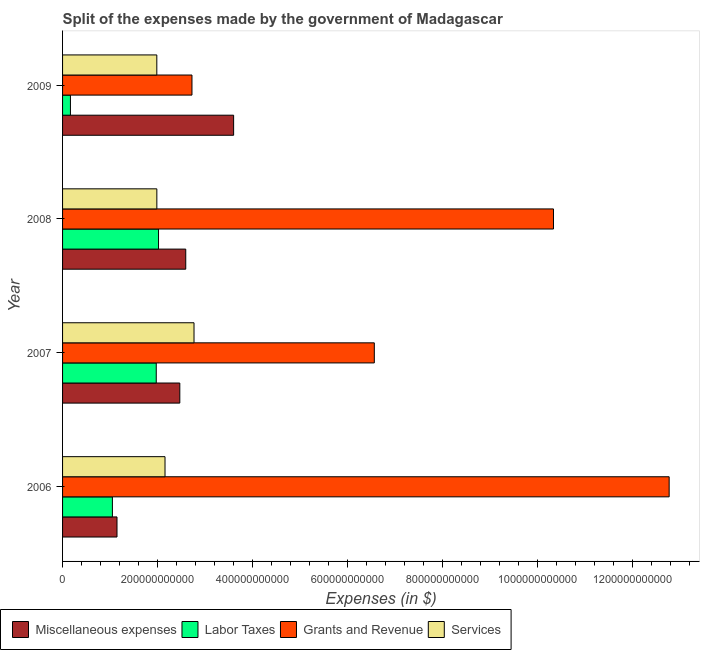How many groups of bars are there?
Offer a very short reply. 4. Are the number of bars on each tick of the Y-axis equal?
Make the answer very short. Yes. How many bars are there on the 4th tick from the top?
Make the answer very short. 4. How many bars are there on the 2nd tick from the bottom?
Offer a terse response. 4. What is the label of the 3rd group of bars from the top?
Give a very brief answer. 2007. What is the amount spent on labor taxes in 2006?
Offer a terse response. 1.05e+11. Across all years, what is the maximum amount spent on grants and revenue?
Keep it short and to the point. 1.28e+12. Across all years, what is the minimum amount spent on labor taxes?
Your response must be concise. 1.66e+1. In which year was the amount spent on labor taxes maximum?
Provide a short and direct response. 2008. In which year was the amount spent on miscellaneous expenses minimum?
Give a very brief answer. 2006. What is the total amount spent on services in the graph?
Ensure brevity in your answer.  8.89e+11. What is the difference between the amount spent on services in 2007 and that in 2009?
Your answer should be compact. 7.83e+1. What is the difference between the amount spent on miscellaneous expenses in 2007 and the amount spent on grants and revenue in 2008?
Offer a very short reply. -7.87e+11. What is the average amount spent on labor taxes per year?
Ensure brevity in your answer.  1.30e+11. In the year 2008, what is the difference between the amount spent on services and amount spent on miscellaneous expenses?
Offer a very short reply. -6.08e+1. In how many years, is the amount spent on grants and revenue greater than 1080000000000 $?
Make the answer very short. 1. What is the difference between the highest and the second highest amount spent on services?
Offer a terse response. 6.11e+1. What is the difference between the highest and the lowest amount spent on grants and revenue?
Ensure brevity in your answer.  1.00e+12. Is the sum of the amount spent on grants and revenue in 2007 and 2009 greater than the maximum amount spent on services across all years?
Offer a terse response. Yes. What does the 3rd bar from the top in 2008 represents?
Your answer should be compact. Labor Taxes. What does the 2nd bar from the bottom in 2009 represents?
Ensure brevity in your answer.  Labor Taxes. Is it the case that in every year, the sum of the amount spent on miscellaneous expenses and amount spent on labor taxes is greater than the amount spent on grants and revenue?
Offer a terse response. No. Are all the bars in the graph horizontal?
Provide a succinct answer. Yes. How many years are there in the graph?
Your answer should be compact. 4. What is the difference between two consecutive major ticks on the X-axis?
Make the answer very short. 2.00e+11. Are the values on the major ticks of X-axis written in scientific E-notation?
Provide a succinct answer. No. What is the title of the graph?
Offer a terse response. Split of the expenses made by the government of Madagascar. Does "Agriculture" appear as one of the legend labels in the graph?
Provide a succinct answer. No. What is the label or title of the X-axis?
Your response must be concise. Expenses (in $). What is the Expenses (in $) in Miscellaneous expenses in 2006?
Ensure brevity in your answer.  1.15e+11. What is the Expenses (in $) of Labor Taxes in 2006?
Provide a succinct answer. 1.05e+11. What is the Expenses (in $) in Grants and Revenue in 2006?
Provide a succinct answer. 1.28e+12. What is the Expenses (in $) in Services in 2006?
Make the answer very short. 2.16e+11. What is the Expenses (in $) in Miscellaneous expenses in 2007?
Provide a succinct answer. 2.47e+11. What is the Expenses (in $) of Labor Taxes in 2007?
Make the answer very short. 1.97e+11. What is the Expenses (in $) in Grants and Revenue in 2007?
Keep it short and to the point. 6.56e+11. What is the Expenses (in $) of Services in 2007?
Provide a succinct answer. 2.77e+11. What is the Expenses (in $) in Miscellaneous expenses in 2008?
Your response must be concise. 2.59e+11. What is the Expenses (in $) of Labor Taxes in 2008?
Your answer should be compact. 2.02e+11. What is the Expenses (in $) of Grants and Revenue in 2008?
Your answer should be very brief. 1.03e+12. What is the Expenses (in $) of Services in 2008?
Your response must be concise. 1.98e+11. What is the Expenses (in $) of Miscellaneous expenses in 2009?
Your answer should be very brief. 3.60e+11. What is the Expenses (in $) of Labor Taxes in 2009?
Offer a terse response. 1.66e+1. What is the Expenses (in $) of Grants and Revenue in 2009?
Provide a short and direct response. 2.72e+11. What is the Expenses (in $) in Services in 2009?
Provide a succinct answer. 1.98e+11. Across all years, what is the maximum Expenses (in $) in Miscellaneous expenses?
Offer a terse response. 3.60e+11. Across all years, what is the maximum Expenses (in $) of Labor Taxes?
Your answer should be compact. 2.02e+11. Across all years, what is the maximum Expenses (in $) of Grants and Revenue?
Offer a terse response. 1.28e+12. Across all years, what is the maximum Expenses (in $) in Services?
Offer a terse response. 2.77e+11. Across all years, what is the minimum Expenses (in $) in Miscellaneous expenses?
Your response must be concise. 1.15e+11. Across all years, what is the minimum Expenses (in $) of Labor Taxes?
Keep it short and to the point. 1.66e+1. Across all years, what is the minimum Expenses (in $) of Grants and Revenue?
Offer a terse response. 2.72e+11. Across all years, what is the minimum Expenses (in $) of Services?
Offer a terse response. 1.98e+11. What is the total Expenses (in $) of Miscellaneous expenses in the graph?
Make the answer very short. 9.81e+11. What is the total Expenses (in $) of Labor Taxes in the graph?
Your answer should be very brief. 5.21e+11. What is the total Expenses (in $) in Grants and Revenue in the graph?
Ensure brevity in your answer.  3.24e+12. What is the total Expenses (in $) of Services in the graph?
Keep it short and to the point. 8.89e+11. What is the difference between the Expenses (in $) in Miscellaneous expenses in 2006 and that in 2007?
Keep it short and to the point. -1.32e+11. What is the difference between the Expenses (in $) of Labor Taxes in 2006 and that in 2007?
Give a very brief answer. -9.23e+1. What is the difference between the Expenses (in $) in Grants and Revenue in 2006 and that in 2007?
Your answer should be compact. 6.21e+11. What is the difference between the Expenses (in $) in Services in 2006 and that in 2007?
Provide a short and direct response. -6.11e+1. What is the difference between the Expenses (in $) of Miscellaneous expenses in 2006 and that in 2008?
Keep it short and to the point. -1.45e+11. What is the difference between the Expenses (in $) of Labor Taxes in 2006 and that in 2008?
Keep it short and to the point. -9.71e+1. What is the difference between the Expenses (in $) of Grants and Revenue in 2006 and that in 2008?
Give a very brief answer. 2.44e+11. What is the difference between the Expenses (in $) of Services in 2006 and that in 2008?
Your response must be concise. 1.72e+1. What is the difference between the Expenses (in $) in Miscellaneous expenses in 2006 and that in 2009?
Your response must be concise. -2.45e+11. What is the difference between the Expenses (in $) of Labor Taxes in 2006 and that in 2009?
Provide a short and direct response. 8.83e+1. What is the difference between the Expenses (in $) in Grants and Revenue in 2006 and that in 2009?
Your answer should be very brief. 1.00e+12. What is the difference between the Expenses (in $) of Services in 2006 and that in 2009?
Keep it short and to the point. 1.73e+1. What is the difference between the Expenses (in $) in Miscellaneous expenses in 2007 and that in 2008?
Your answer should be compact. -1.25e+1. What is the difference between the Expenses (in $) of Labor Taxes in 2007 and that in 2008?
Offer a terse response. -4.78e+09. What is the difference between the Expenses (in $) in Grants and Revenue in 2007 and that in 2008?
Provide a short and direct response. -3.77e+11. What is the difference between the Expenses (in $) of Services in 2007 and that in 2008?
Offer a very short reply. 7.82e+1. What is the difference between the Expenses (in $) in Miscellaneous expenses in 2007 and that in 2009?
Your answer should be compact. -1.13e+11. What is the difference between the Expenses (in $) of Labor Taxes in 2007 and that in 2009?
Your answer should be compact. 1.81e+11. What is the difference between the Expenses (in $) in Grants and Revenue in 2007 and that in 2009?
Provide a succinct answer. 3.84e+11. What is the difference between the Expenses (in $) of Services in 2007 and that in 2009?
Your answer should be very brief. 7.83e+1. What is the difference between the Expenses (in $) of Miscellaneous expenses in 2008 and that in 2009?
Provide a short and direct response. -1.01e+11. What is the difference between the Expenses (in $) of Labor Taxes in 2008 and that in 2009?
Your answer should be compact. 1.85e+11. What is the difference between the Expenses (in $) in Grants and Revenue in 2008 and that in 2009?
Provide a short and direct response. 7.61e+11. What is the difference between the Expenses (in $) of Services in 2008 and that in 2009?
Your answer should be very brief. 9.30e+07. What is the difference between the Expenses (in $) of Miscellaneous expenses in 2006 and the Expenses (in $) of Labor Taxes in 2007?
Ensure brevity in your answer.  -8.26e+1. What is the difference between the Expenses (in $) in Miscellaneous expenses in 2006 and the Expenses (in $) in Grants and Revenue in 2007?
Make the answer very short. -5.42e+11. What is the difference between the Expenses (in $) of Miscellaneous expenses in 2006 and the Expenses (in $) of Services in 2007?
Your response must be concise. -1.62e+11. What is the difference between the Expenses (in $) of Labor Taxes in 2006 and the Expenses (in $) of Grants and Revenue in 2007?
Your answer should be very brief. -5.51e+11. What is the difference between the Expenses (in $) in Labor Taxes in 2006 and the Expenses (in $) in Services in 2007?
Provide a short and direct response. -1.72e+11. What is the difference between the Expenses (in $) of Grants and Revenue in 2006 and the Expenses (in $) of Services in 2007?
Make the answer very short. 1.00e+12. What is the difference between the Expenses (in $) of Miscellaneous expenses in 2006 and the Expenses (in $) of Labor Taxes in 2008?
Your response must be concise. -8.74e+1. What is the difference between the Expenses (in $) of Miscellaneous expenses in 2006 and the Expenses (in $) of Grants and Revenue in 2008?
Your response must be concise. -9.19e+11. What is the difference between the Expenses (in $) in Miscellaneous expenses in 2006 and the Expenses (in $) in Services in 2008?
Offer a very short reply. -8.39e+1. What is the difference between the Expenses (in $) in Labor Taxes in 2006 and the Expenses (in $) in Grants and Revenue in 2008?
Provide a succinct answer. -9.28e+11. What is the difference between the Expenses (in $) in Labor Taxes in 2006 and the Expenses (in $) in Services in 2008?
Your answer should be compact. -9.36e+1. What is the difference between the Expenses (in $) of Grants and Revenue in 2006 and the Expenses (in $) of Services in 2008?
Make the answer very short. 1.08e+12. What is the difference between the Expenses (in $) of Miscellaneous expenses in 2006 and the Expenses (in $) of Labor Taxes in 2009?
Make the answer very short. 9.80e+1. What is the difference between the Expenses (in $) in Miscellaneous expenses in 2006 and the Expenses (in $) in Grants and Revenue in 2009?
Ensure brevity in your answer.  -1.58e+11. What is the difference between the Expenses (in $) in Miscellaneous expenses in 2006 and the Expenses (in $) in Services in 2009?
Make the answer very short. -8.38e+1. What is the difference between the Expenses (in $) in Labor Taxes in 2006 and the Expenses (in $) in Grants and Revenue in 2009?
Offer a terse response. -1.68e+11. What is the difference between the Expenses (in $) of Labor Taxes in 2006 and the Expenses (in $) of Services in 2009?
Give a very brief answer. -9.35e+1. What is the difference between the Expenses (in $) in Grants and Revenue in 2006 and the Expenses (in $) in Services in 2009?
Your answer should be compact. 1.08e+12. What is the difference between the Expenses (in $) of Miscellaneous expenses in 2007 and the Expenses (in $) of Labor Taxes in 2008?
Ensure brevity in your answer.  4.48e+1. What is the difference between the Expenses (in $) of Miscellaneous expenses in 2007 and the Expenses (in $) of Grants and Revenue in 2008?
Provide a short and direct response. -7.87e+11. What is the difference between the Expenses (in $) in Miscellaneous expenses in 2007 and the Expenses (in $) in Services in 2008?
Keep it short and to the point. 4.83e+1. What is the difference between the Expenses (in $) in Labor Taxes in 2007 and the Expenses (in $) in Grants and Revenue in 2008?
Offer a terse response. -8.36e+11. What is the difference between the Expenses (in $) of Labor Taxes in 2007 and the Expenses (in $) of Services in 2008?
Your response must be concise. -1.25e+09. What is the difference between the Expenses (in $) in Grants and Revenue in 2007 and the Expenses (in $) in Services in 2008?
Ensure brevity in your answer.  4.58e+11. What is the difference between the Expenses (in $) in Miscellaneous expenses in 2007 and the Expenses (in $) in Labor Taxes in 2009?
Offer a terse response. 2.30e+11. What is the difference between the Expenses (in $) in Miscellaneous expenses in 2007 and the Expenses (in $) in Grants and Revenue in 2009?
Your answer should be very brief. -2.56e+1. What is the difference between the Expenses (in $) of Miscellaneous expenses in 2007 and the Expenses (in $) of Services in 2009?
Your response must be concise. 4.84e+1. What is the difference between the Expenses (in $) of Labor Taxes in 2007 and the Expenses (in $) of Grants and Revenue in 2009?
Keep it short and to the point. -7.52e+1. What is the difference between the Expenses (in $) in Labor Taxes in 2007 and the Expenses (in $) in Services in 2009?
Keep it short and to the point. -1.15e+09. What is the difference between the Expenses (in $) of Grants and Revenue in 2007 and the Expenses (in $) of Services in 2009?
Keep it short and to the point. 4.58e+11. What is the difference between the Expenses (in $) in Miscellaneous expenses in 2008 and the Expenses (in $) in Labor Taxes in 2009?
Your response must be concise. 2.43e+11. What is the difference between the Expenses (in $) in Miscellaneous expenses in 2008 and the Expenses (in $) in Grants and Revenue in 2009?
Ensure brevity in your answer.  -1.31e+1. What is the difference between the Expenses (in $) of Miscellaneous expenses in 2008 and the Expenses (in $) of Services in 2009?
Your response must be concise. 6.09e+1. What is the difference between the Expenses (in $) of Labor Taxes in 2008 and the Expenses (in $) of Grants and Revenue in 2009?
Your answer should be very brief. -7.04e+1. What is the difference between the Expenses (in $) of Labor Taxes in 2008 and the Expenses (in $) of Services in 2009?
Your response must be concise. 3.62e+09. What is the difference between the Expenses (in $) of Grants and Revenue in 2008 and the Expenses (in $) of Services in 2009?
Make the answer very short. 8.35e+11. What is the average Expenses (in $) in Miscellaneous expenses per year?
Offer a terse response. 2.45e+11. What is the average Expenses (in $) in Labor Taxes per year?
Your answer should be very brief. 1.30e+11. What is the average Expenses (in $) of Grants and Revenue per year?
Offer a very short reply. 8.10e+11. What is the average Expenses (in $) of Services per year?
Your response must be concise. 2.22e+11. In the year 2006, what is the difference between the Expenses (in $) of Miscellaneous expenses and Expenses (in $) of Labor Taxes?
Give a very brief answer. 9.70e+09. In the year 2006, what is the difference between the Expenses (in $) of Miscellaneous expenses and Expenses (in $) of Grants and Revenue?
Offer a very short reply. -1.16e+12. In the year 2006, what is the difference between the Expenses (in $) of Miscellaneous expenses and Expenses (in $) of Services?
Your answer should be compact. -1.01e+11. In the year 2006, what is the difference between the Expenses (in $) in Labor Taxes and Expenses (in $) in Grants and Revenue?
Keep it short and to the point. -1.17e+12. In the year 2006, what is the difference between the Expenses (in $) in Labor Taxes and Expenses (in $) in Services?
Your response must be concise. -1.11e+11. In the year 2006, what is the difference between the Expenses (in $) in Grants and Revenue and Expenses (in $) in Services?
Make the answer very short. 1.06e+12. In the year 2007, what is the difference between the Expenses (in $) of Miscellaneous expenses and Expenses (in $) of Labor Taxes?
Give a very brief answer. 4.96e+1. In the year 2007, what is the difference between the Expenses (in $) of Miscellaneous expenses and Expenses (in $) of Grants and Revenue?
Give a very brief answer. -4.09e+11. In the year 2007, what is the difference between the Expenses (in $) of Miscellaneous expenses and Expenses (in $) of Services?
Keep it short and to the point. -2.99e+1. In the year 2007, what is the difference between the Expenses (in $) of Labor Taxes and Expenses (in $) of Grants and Revenue?
Provide a succinct answer. -4.59e+11. In the year 2007, what is the difference between the Expenses (in $) of Labor Taxes and Expenses (in $) of Services?
Keep it short and to the point. -7.95e+1. In the year 2007, what is the difference between the Expenses (in $) in Grants and Revenue and Expenses (in $) in Services?
Your answer should be compact. 3.80e+11. In the year 2008, what is the difference between the Expenses (in $) of Miscellaneous expenses and Expenses (in $) of Labor Taxes?
Provide a succinct answer. 5.73e+1. In the year 2008, what is the difference between the Expenses (in $) of Miscellaneous expenses and Expenses (in $) of Grants and Revenue?
Your answer should be compact. -7.74e+11. In the year 2008, what is the difference between the Expenses (in $) in Miscellaneous expenses and Expenses (in $) in Services?
Your answer should be very brief. 6.08e+1. In the year 2008, what is the difference between the Expenses (in $) of Labor Taxes and Expenses (in $) of Grants and Revenue?
Ensure brevity in your answer.  -8.31e+11. In the year 2008, what is the difference between the Expenses (in $) of Labor Taxes and Expenses (in $) of Services?
Provide a short and direct response. 3.53e+09. In the year 2008, what is the difference between the Expenses (in $) of Grants and Revenue and Expenses (in $) of Services?
Keep it short and to the point. 8.35e+11. In the year 2009, what is the difference between the Expenses (in $) in Miscellaneous expenses and Expenses (in $) in Labor Taxes?
Your answer should be very brief. 3.44e+11. In the year 2009, what is the difference between the Expenses (in $) in Miscellaneous expenses and Expenses (in $) in Grants and Revenue?
Offer a terse response. 8.77e+1. In the year 2009, what is the difference between the Expenses (in $) of Miscellaneous expenses and Expenses (in $) of Services?
Offer a very short reply. 1.62e+11. In the year 2009, what is the difference between the Expenses (in $) of Labor Taxes and Expenses (in $) of Grants and Revenue?
Make the answer very short. -2.56e+11. In the year 2009, what is the difference between the Expenses (in $) of Labor Taxes and Expenses (in $) of Services?
Keep it short and to the point. -1.82e+11. In the year 2009, what is the difference between the Expenses (in $) of Grants and Revenue and Expenses (in $) of Services?
Offer a very short reply. 7.40e+1. What is the ratio of the Expenses (in $) in Miscellaneous expenses in 2006 to that in 2007?
Provide a short and direct response. 0.46. What is the ratio of the Expenses (in $) of Labor Taxes in 2006 to that in 2007?
Make the answer very short. 0.53. What is the ratio of the Expenses (in $) of Grants and Revenue in 2006 to that in 2007?
Ensure brevity in your answer.  1.95. What is the ratio of the Expenses (in $) of Services in 2006 to that in 2007?
Offer a terse response. 0.78. What is the ratio of the Expenses (in $) of Miscellaneous expenses in 2006 to that in 2008?
Offer a terse response. 0.44. What is the ratio of the Expenses (in $) in Labor Taxes in 2006 to that in 2008?
Give a very brief answer. 0.52. What is the ratio of the Expenses (in $) of Grants and Revenue in 2006 to that in 2008?
Provide a short and direct response. 1.24. What is the ratio of the Expenses (in $) in Services in 2006 to that in 2008?
Provide a short and direct response. 1.09. What is the ratio of the Expenses (in $) of Miscellaneous expenses in 2006 to that in 2009?
Your answer should be very brief. 0.32. What is the ratio of the Expenses (in $) in Labor Taxes in 2006 to that in 2009?
Provide a short and direct response. 6.33. What is the ratio of the Expenses (in $) in Grants and Revenue in 2006 to that in 2009?
Ensure brevity in your answer.  4.69. What is the ratio of the Expenses (in $) of Services in 2006 to that in 2009?
Give a very brief answer. 1.09. What is the ratio of the Expenses (in $) in Miscellaneous expenses in 2007 to that in 2008?
Make the answer very short. 0.95. What is the ratio of the Expenses (in $) in Labor Taxes in 2007 to that in 2008?
Offer a very short reply. 0.98. What is the ratio of the Expenses (in $) of Grants and Revenue in 2007 to that in 2008?
Provide a short and direct response. 0.64. What is the ratio of the Expenses (in $) in Services in 2007 to that in 2008?
Provide a short and direct response. 1.39. What is the ratio of the Expenses (in $) of Miscellaneous expenses in 2007 to that in 2009?
Your response must be concise. 0.69. What is the ratio of the Expenses (in $) of Labor Taxes in 2007 to that in 2009?
Give a very brief answer. 11.91. What is the ratio of the Expenses (in $) in Grants and Revenue in 2007 to that in 2009?
Offer a terse response. 2.41. What is the ratio of the Expenses (in $) of Services in 2007 to that in 2009?
Offer a terse response. 1.39. What is the ratio of the Expenses (in $) of Miscellaneous expenses in 2008 to that in 2009?
Ensure brevity in your answer.  0.72. What is the ratio of the Expenses (in $) in Labor Taxes in 2008 to that in 2009?
Give a very brief answer. 12.2. What is the ratio of the Expenses (in $) of Grants and Revenue in 2008 to that in 2009?
Your answer should be very brief. 3.79. What is the ratio of the Expenses (in $) of Services in 2008 to that in 2009?
Your answer should be very brief. 1. What is the difference between the highest and the second highest Expenses (in $) in Miscellaneous expenses?
Your response must be concise. 1.01e+11. What is the difference between the highest and the second highest Expenses (in $) of Labor Taxes?
Keep it short and to the point. 4.78e+09. What is the difference between the highest and the second highest Expenses (in $) of Grants and Revenue?
Your answer should be very brief. 2.44e+11. What is the difference between the highest and the second highest Expenses (in $) in Services?
Your answer should be very brief. 6.11e+1. What is the difference between the highest and the lowest Expenses (in $) in Miscellaneous expenses?
Offer a terse response. 2.45e+11. What is the difference between the highest and the lowest Expenses (in $) in Labor Taxes?
Provide a short and direct response. 1.85e+11. What is the difference between the highest and the lowest Expenses (in $) of Grants and Revenue?
Offer a terse response. 1.00e+12. What is the difference between the highest and the lowest Expenses (in $) of Services?
Make the answer very short. 7.83e+1. 